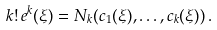Convert formula to latex. <formula><loc_0><loc_0><loc_500><loc_500>k ! \, e ^ { k } ( \xi ) = N _ { k } ( c _ { 1 } ( \xi ) , \dots , c _ { k } ( \xi ) ) \, .</formula> 